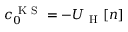Convert formula to latex. <formula><loc_0><loc_0><loc_500><loc_500>c _ { 0 } ^ { K S } = - U _ { H } [ n ]</formula> 